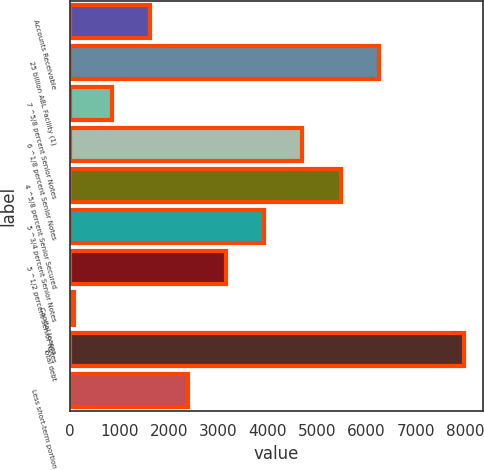Convert chart. <chart><loc_0><loc_0><loc_500><loc_500><bar_chart><fcel>Accounts Receivable<fcel>25 billion ABL Facility (1)<fcel>7 ^5/8 percent Senior Notes<fcel>6 ^1/8 percent Senior Notes<fcel>4 ^5/8 percent Senior Secured<fcel>5 ^3/4 percent Senior Notes<fcel>5 ^1/2 percent Senior Notes<fcel>Capital leases<fcel>Total debt<fcel>Less short-term portion<nl><fcel>1614.8<fcel>6246.2<fcel>842.9<fcel>4702.4<fcel>5474.3<fcel>3930.5<fcel>3158.6<fcel>71<fcel>7964.9<fcel>2386.7<nl></chart> 